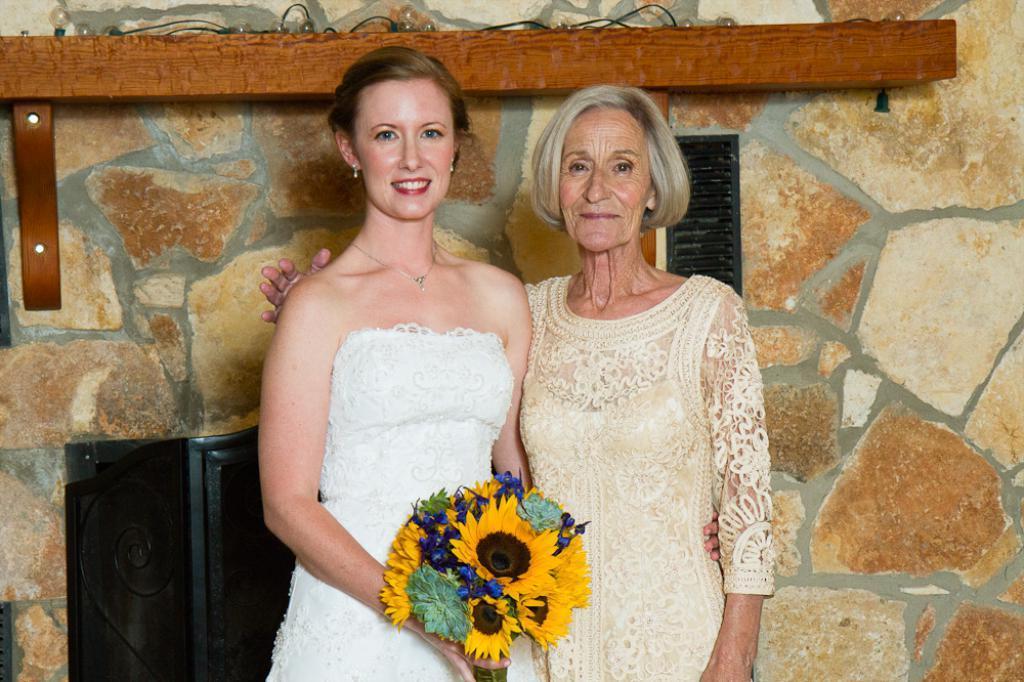Describe this image in one or two sentences. This image consists of two women. On the left, the women wearing white dress is holding the flowers. On the right, the woman wearing a cream dress. In the background, we can see a wall on which, there is a rack made up of wood. Behind them, there is an object in black color. 